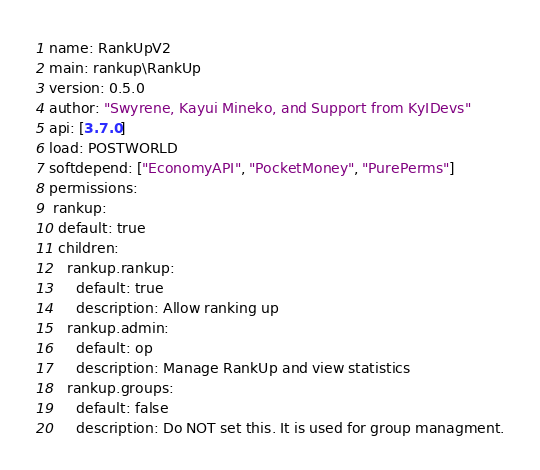Convert code to text. <code><loc_0><loc_0><loc_500><loc_500><_YAML_>name: RankUpV2
main: rankup\RankUp
version: 0.5.0
author: "Swyrene, Kayui Mineko, and Support from KyIDevs"
api: [3.7.0]
load: POSTWORLD
softdepend: ["EconomyAPI", "PocketMoney", "PurePerms"]
permissions:
 rankup:
  default: true
  children:
    rankup.rankup:
      default: true
      description: Allow ranking up
    rankup.admin:
      default: op
      description: Manage RankUp and view statistics
    rankup.groups:
      default: false
      description: Do NOT set this. It is used for group managment.
</code> 